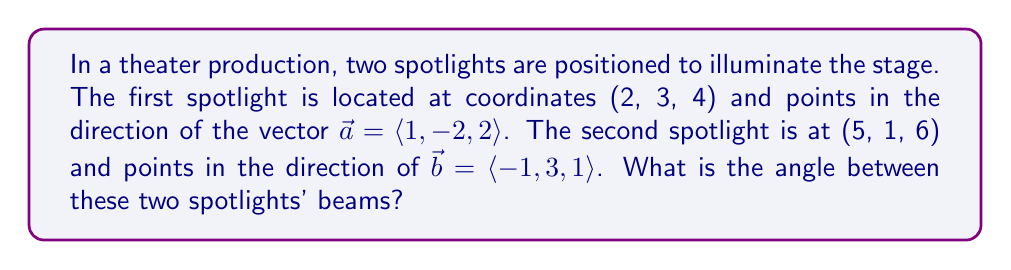Can you solve this math problem? To find the angle between two vectors in 3D space, we can use the dot product formula:

$$\cos \theta = \frac{\vec{a} \cdot \vec{b}}{|\vec{a}||\vec{b}|}$$

Step 1: Calculate the dot product $\vec{a} \cdot \vec{b}$
$$\vec{a} \cdot \vec{b} = (1)(-1) + (-2)(3) + (2)(1) = -1 - 6 + 2 = -5$$

Step 2: Calculate the magnitudes of $\vec{a}$ and $\vec{b}$
$$|\vec{a}| = \sqrt{1^2 + (-2)^2 + 2^2} = \sqrt{1 + 4 + 4} = \sqrt{9} = 3$$
$$|\vec{b}| = \sqrt{(-1)^2 + 3^2 + 1^2} = \sqrt{1 + 9 + 1} = \sqrt{11}$$

Step 3: Substitute into the formula
$$\cos \theta = \frac{-5}{3\sqrt{11}}$$

Step 4: Take the inverse cosine (arccos) of both sides
$$\theta = \arccos\left(\frac{-5}{3\sqrt{11}}\right)$$

Step 5: Calculate the result (in radians)
$$\theta \approx 2.0344 \text{ radians}$$

Step 6: Convert to degrees
$$\theta \approx 116.57°$$
Answer: $116.57°$ 